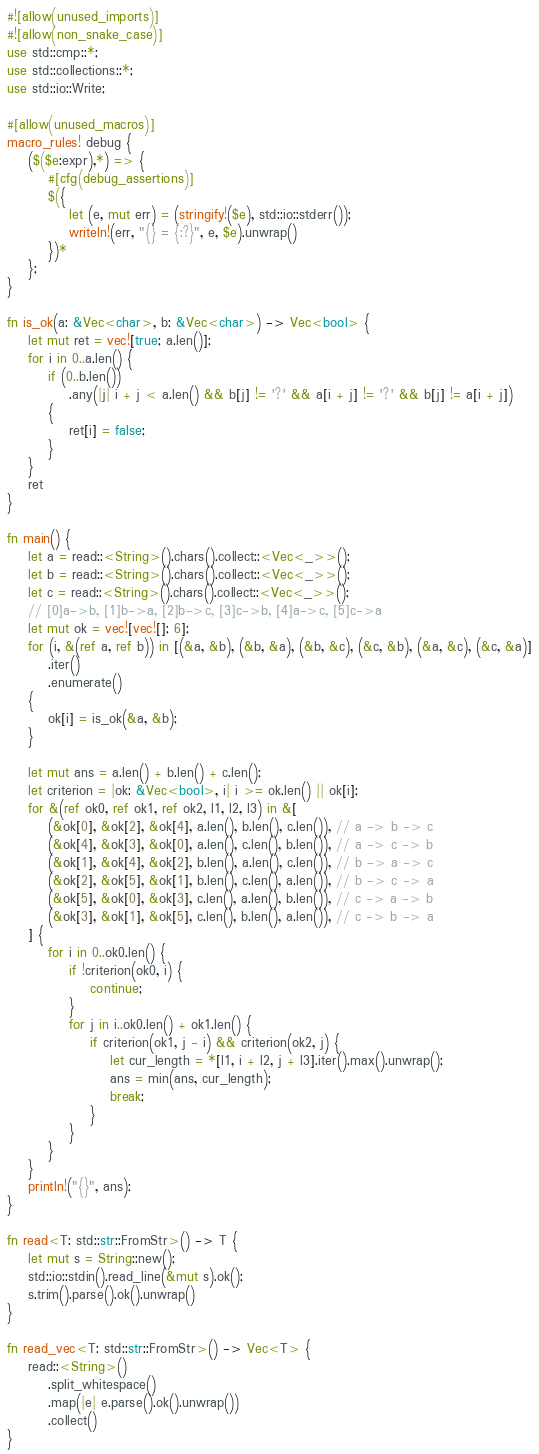Convert code to text. <code><loc_0><loc_0><loc_500><loc_500><_Rust_>#![allow(unused_imports)]
#![allow(non_snake_case)]
use std::cmp::*;
use std::collections::*;
use std::io::Write;

#[allow(unused_macros)]
macro_rules! debug {
    ($($e:expr),*) => {
        #[cfg(debug_assertions)]
        $({
            let (e, mut err) = (stringify!($e), std::io::stderr());
            writeln!(err, "{} = {:?}", e, $e).unwrap()
        })*
    };
}

fn is_ok(a: &Vec<char>, b: &Vec<char>) -> Vec<bool> {
    let mut ret = vec![true; a.len()];
    for i in 0..a.len() {
        if (0..b.len())
            .any(|j| i + j < a.len() && b[j] != '?' && a[i + j] != '?' && b[j] != a[i + j])
        {
            ret[i] = false;
        }
    }
    ret
}

fn main() {
    let a = read::<String>().chars().collect::<Vec<_>>();
    let b = read::<String>().chars().collect::<Vec<_>>();
    let c = read::<String>().chars().collect::<Vec<_>>();
    // [0]a->b, [1]b->a, [2]b->c, [3]c->b, [4]a->c, [5]c->a
    let mut ok = vec![vec![]; 6];
    for (i, &(ref a, ref b)) in [(&a, &b), (&b, &a), (&b, &c), (&c, &b), (&a, &c), (&c, &a)]
        .iter()
        .enumerate()
    {
        ok[i] = is_ok(&a, &b);
    }

    let mut ans = a.len() + b.len() + c.len();
    let criterion = |ok: &Vec<bool>, i| i >= ok.len() || ok[i];
    for &(ref ok0, ref ok1, ref ok2, l1, l2, l3) in &[
        (&ok[0], &ok[2], &ok[4], a.len(), b.len(), c.len()), // a -> b -> c
        (&ok[4], &ok[3], &ok[0], a.len(), c.len(), b.len()), // a -> c -> b
        (&ok[1], &ok[4], &ok[2], b.len(), a.len(), c.len()), // b -> a -> c
        (&ok[2], &ok[5], &ok[1], b.len(), c.len(), a.len()), // b -> c -> a
        (&ok[5], &ok[0], &ok[3], c.len(), a.len(), b.len()), // c -> a -> b
        (&ok[3], &ok[1], &ok[5], c.len(), b.len(), a.len()), // c -> b -> a
    ] {
        for i in 0..ok0.len() {
            if !criterion(ok0, i) {
                continue;
            }
            for j in i..ok0.len() + ok1.len() {
                if criterion(ok1, j - i) && criterion(ok2, j) {
                    let cur_length = *[l1, i + l2, j + l3].iter().max().unwrap();
                    ans = min(ans, cur_length);
                    break;
                }
            }
        }
    }
    println!("{}", ans);
}

fn read<T: std::str::FromStr>() -> T {
    let mut s = String::new();
    std::io::stdin().read_line(&mut s).ok();
    s.trim().parse().ok().unwrap()
}

fn read_vec<T: std::str::FromStr>() -> Vec<T> {
    read::<String>()
        .split_whitespace()
        .map(|e| e.parse().ok().unwrap())
        .collect()
}
</code> 